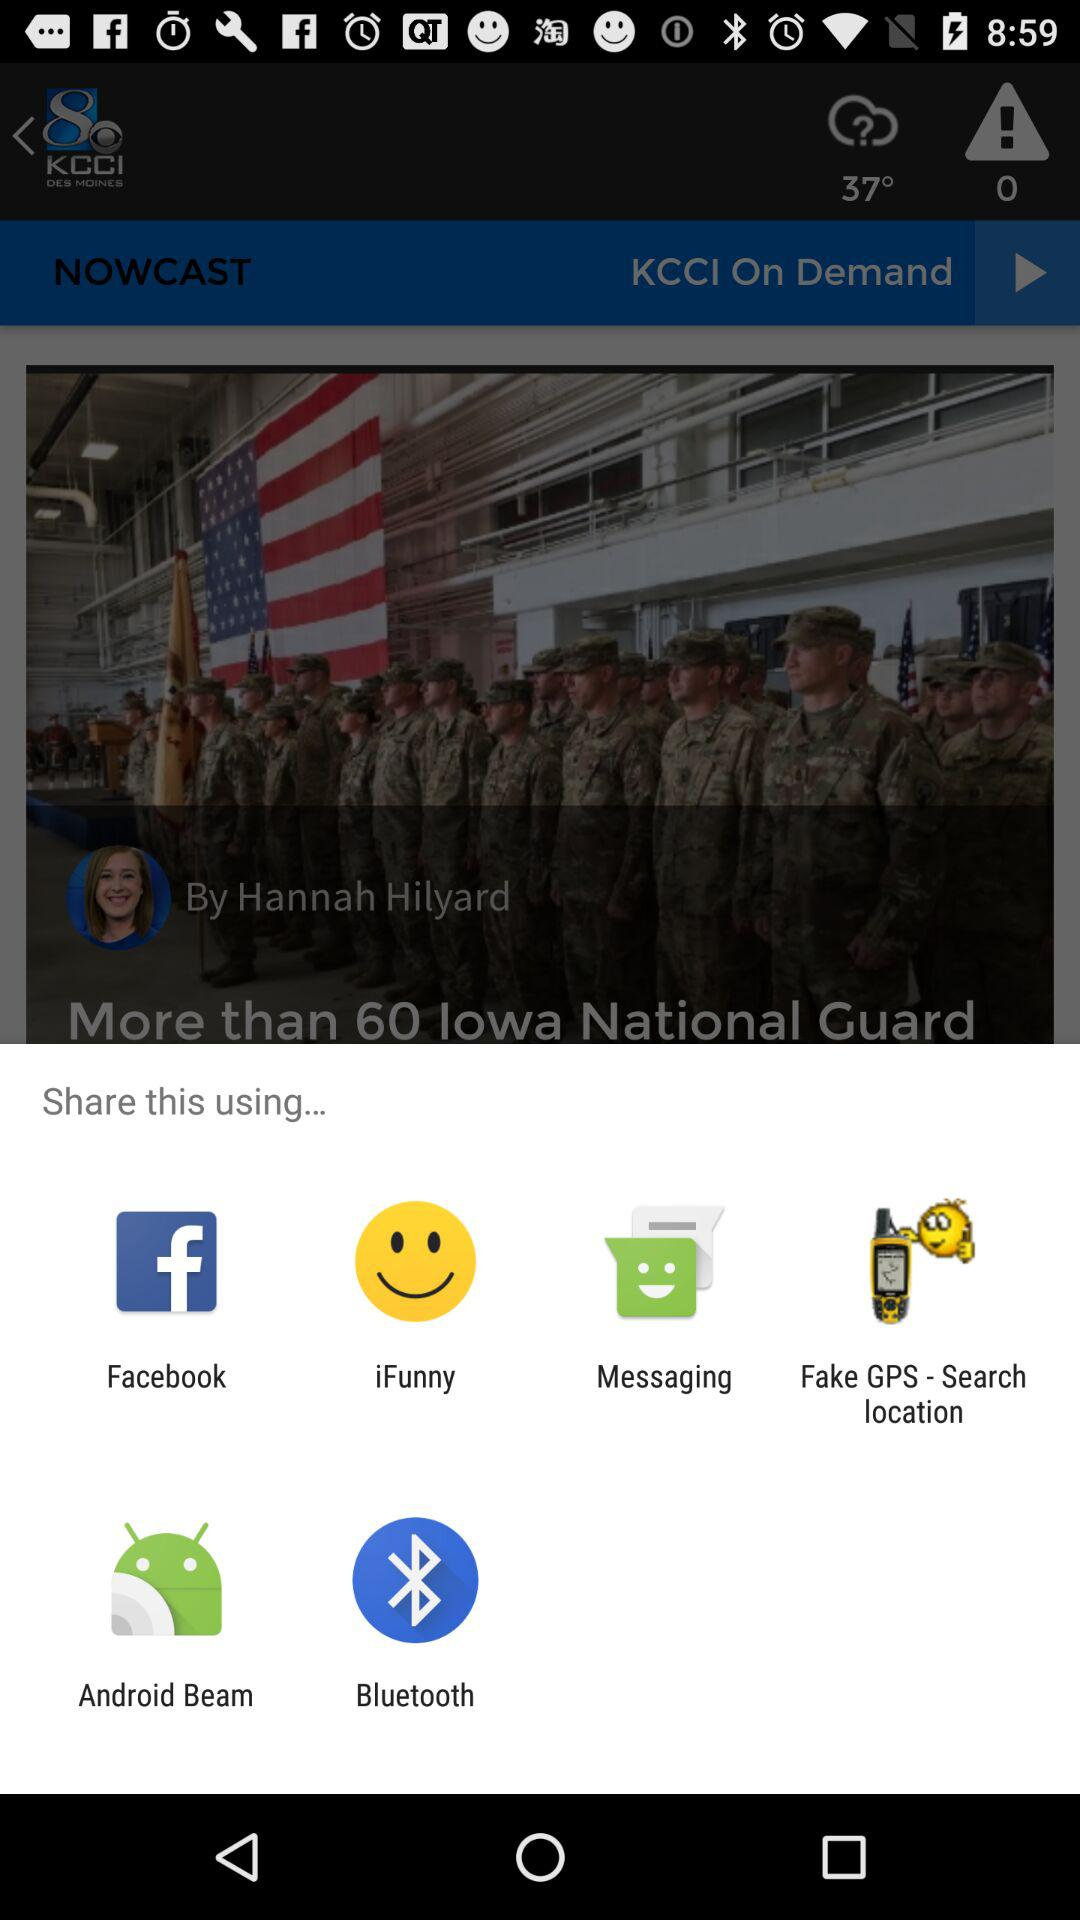What is the temperature? The temperature is 37°. 